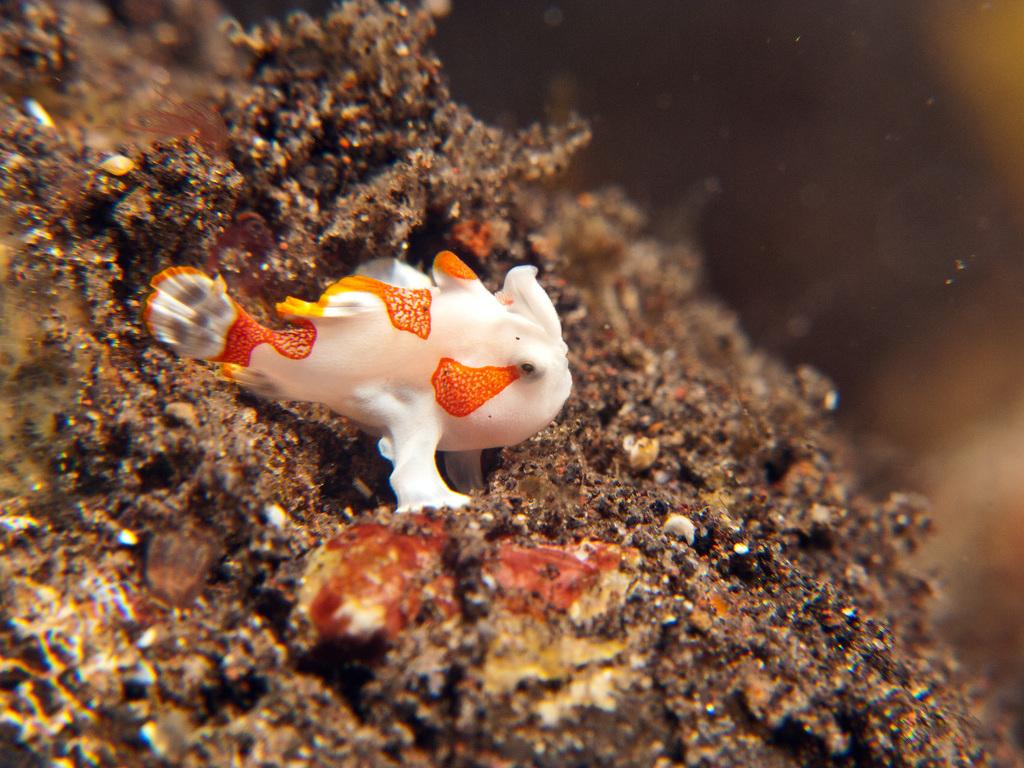What type of animal is in the image? There is a fish in the image. What else can be seen in the water with the fish? There are corals in the image. Can you describe the environment where the fish and corals are located? The fish and corals are in the water. What type of roof can be seen above the fish and corals in the image? There is no roof present in the image, as it features a fish and corals in the water. 